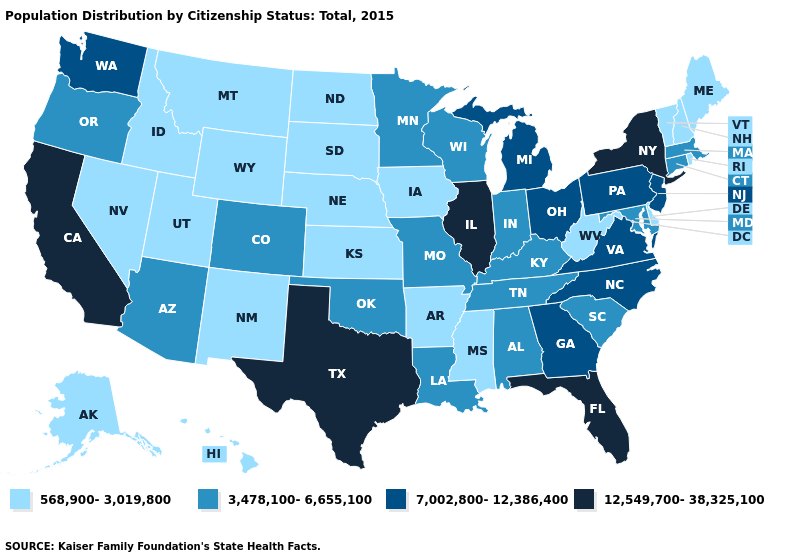What is the lowest value in the MidWest?
Short answer required. 568,900-3,019,800. What is the lowest value in states that border Ohio?
Answer briefly. 568,900-3,019,800. Which states have the highest value in the USA?
Answer briefly. California, Florida, Illinois, New York, Texas. Does Kansas have the same value as Rhode Island?
Concise answer only. Yes. How many symbols are there in the legend?
Keep it brief. 4. Name the states that have a value in the range 568,900-3,019,800?
Short answer required. Alaska, Arkansas, Delaware, Hawaii, Idaho, Iowa, Kansas, Maine, Mississippi, Montana, Nebraska, Nevada, New Hampshire, New Mexico, North Dakota, Rhode Island, South Dakota, Utah, Vermont, West Virginia, Wyoming. Which states have the lowest value in the USA?
Give a very brief answer. Alaska, Arkansas, Delaware, Hawaii, Idaho, Iowa, Kansas, Maine, Mississippi, Montana, Nebraska, Nevada, New Hampshire, New Mexico, North Dakota, Rhode Island, South Dakota, Utah, Vermont, West Virginia, Wyoming. Among the states that border Missouri , which have the highest value?
Concise answer only. Illinois. Does Alabama have the lowest value in the USA?
Short answer required. No. What is the lowest value in states that border Missouri?
Concise answer only. 568,900-3,019,800. Does Florida have the highest value in the USA?
Keep it brief. Yes. Name the states that have a value in the range 7,002,800-12,386,400?
Concise answer only. Georgia, Michigan, New Jersey, North Carolina, Ohio, Pennsylvania, Virginia, Washington. Name the states that have a value in the range 3,478,100-6,655,100?
Be succinct. Alabama, Arizona, Colorado, Connecticut, Indiana, Kentucky, Louisiana, Maryland, Massachusetts, Minnesota, Missouri, Oklahoma, Oregon, South Carolina, Tennessee, Wisconsin. What is the value of Kansas?
Be succinct. 568,900-3,019,800. Does Kansas have the lowest value in the USA?
Be succinct. Yes. 